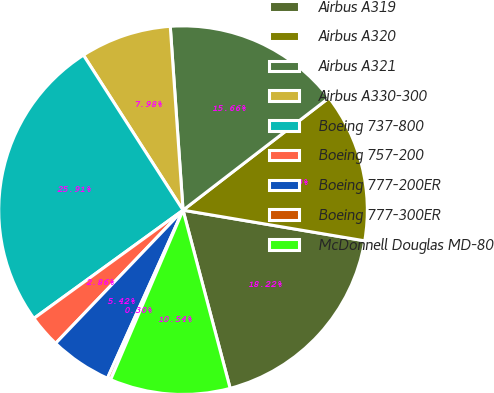Convert chart. <chart><loc_0><loc_0><loc_500><loc_500><pie_chart><fcel>Airbus A319<fcel>Airbus A320<fcel>Airbus A321<fcel>Airbus A330-300<fcel>Boeing 737-800<fcel>Boeing 757-200<fcel>Boeing 777-200ER<fcel>Boeing 777-300ER<fcel>McDonnell Douglas MD-80<nl><fcel>18.22%<fcel>13.1%<fcel>15.66%<fcel>7.98%<fcel>25.9%<fcel>2.86%<fcel>5.42%<fcel>0.3%<fcel>10.54%<nl></chart> 